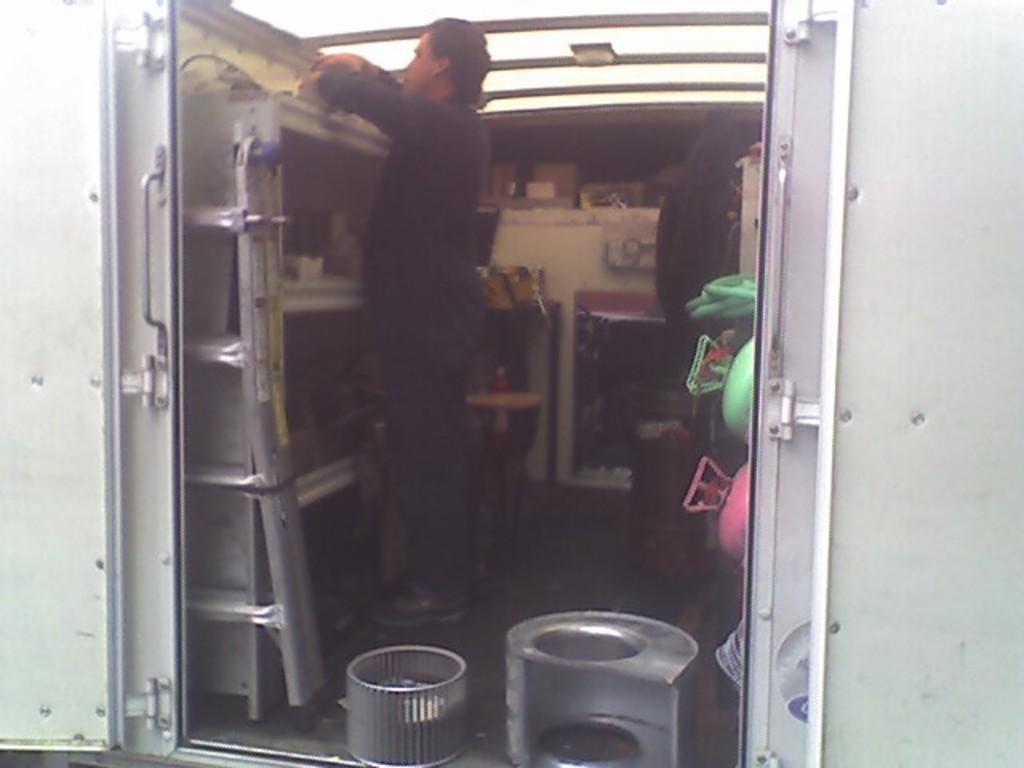Can you describe this image briefly? In this picture I can see there is a man standing here and he is holding a object, there are few shelves and there is a sliding door and it has a handle. There are few objects on the floor and there is a person standing in the backdrop at right side and there is a pink and green color objects placed on top right side. 